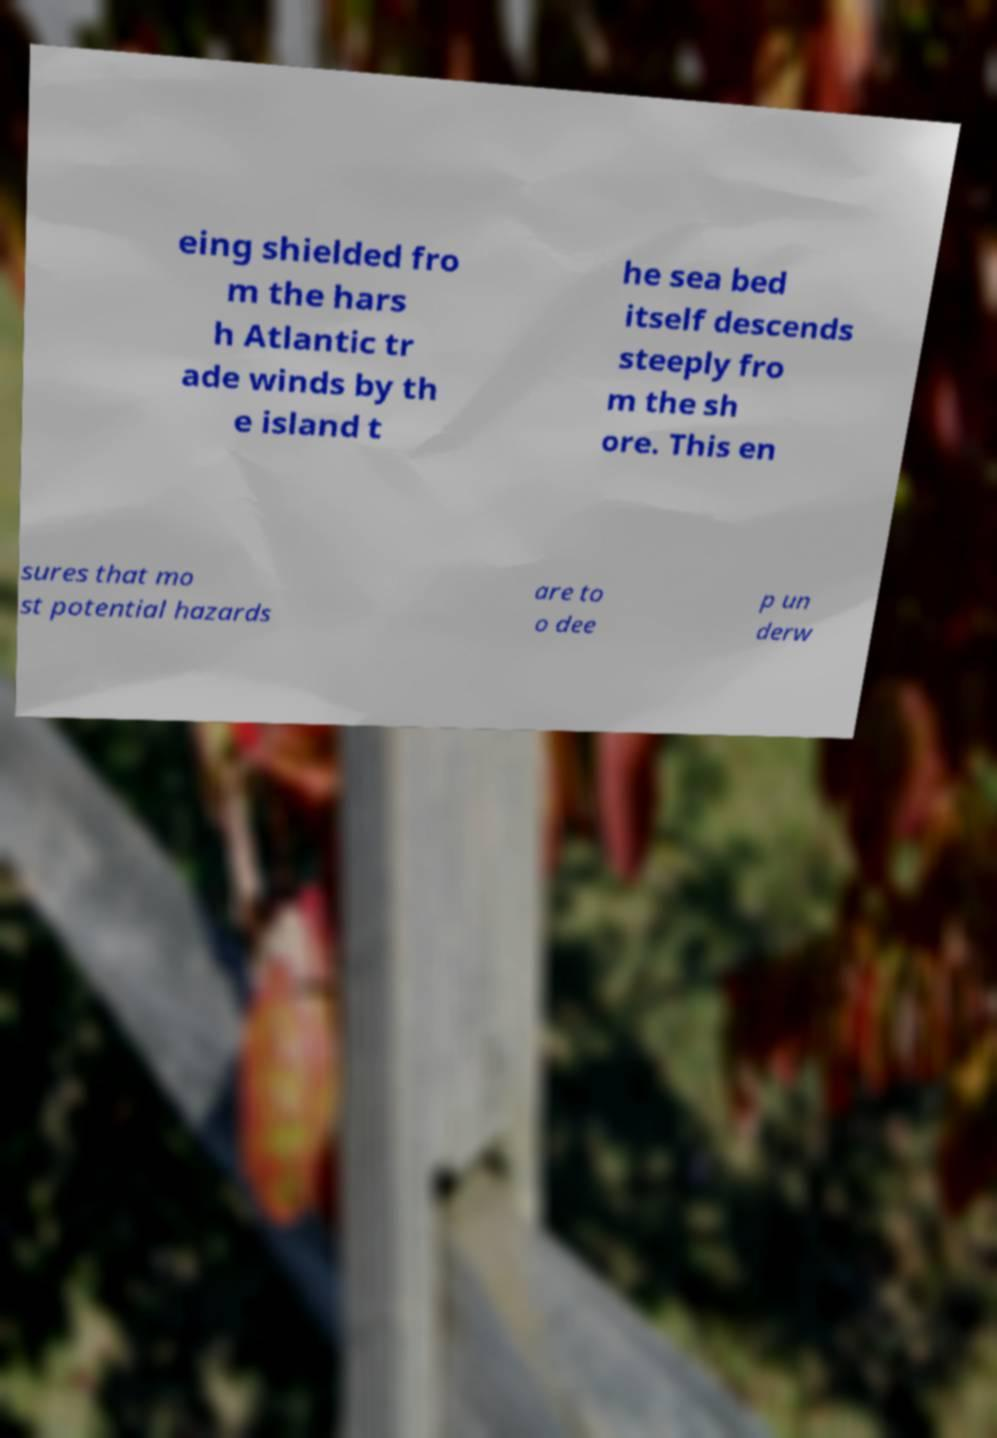For documentation purposes, I need the text within this image transcribed. Could you provide that? eing shielded fro m the hars h Atlantic tr ade winds by th e island t he sea bed itself descends steeply fro m the sh ore. This en sures that mo st potential hazards are to o dee p un derw 